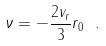Convert formula to latex. <formula><loc_0><loc_0><loc_500><loc_500>\nu = - \frac { 2 v _ { r } } { 3 } r _ { 0 } \ .</formula> 